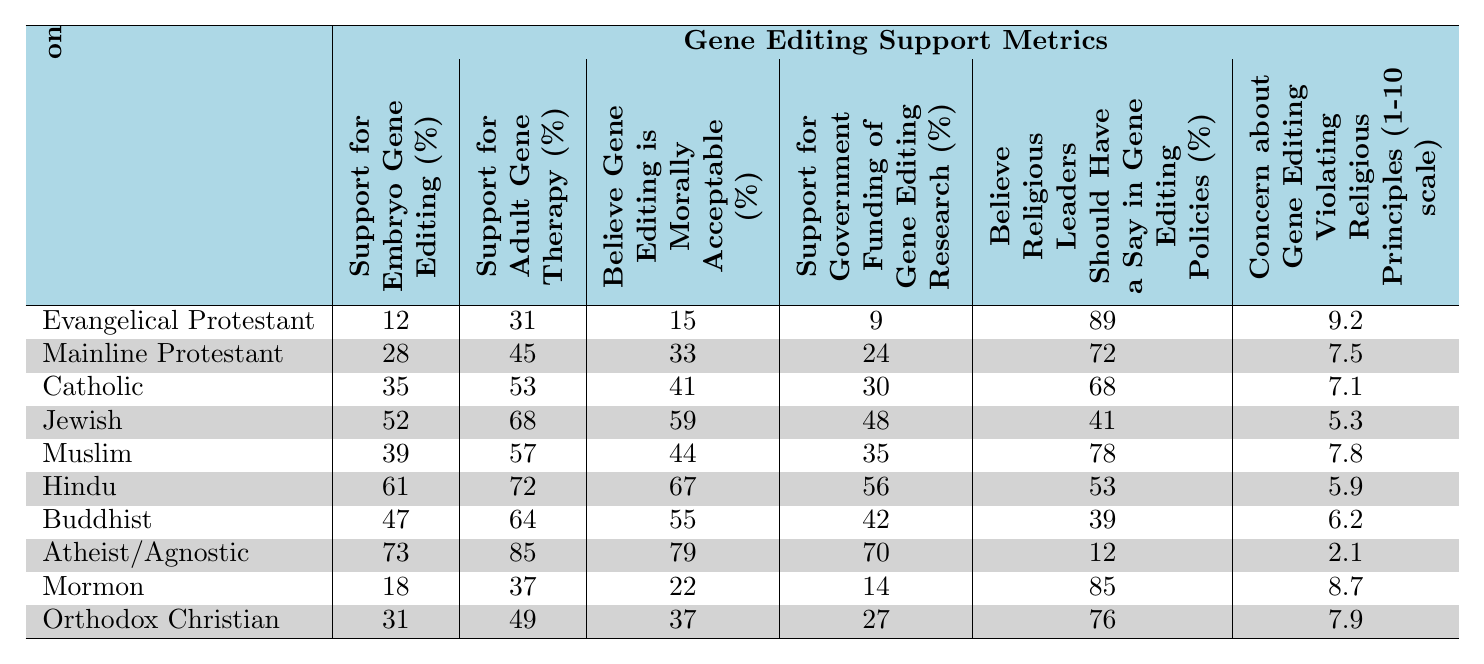What is the support percentage for embryo gene editing among Atheists/Agnostics? According to the table, the support percentage for embryo gene editing among Atheists/Agnostics is 73%.
Answer: 73% Which religious group has the highest support for adult gene therapy? The table shows that Atheists/Agnostics have the highest support for adult gene therapy at 85%.
Answer: 85% Do Evangelical Protestants believe gene editing is morally acceptable? Yes, according to the table, only 15% of Evangelical Protestants believe gene editing is morally acceptable.
Answer: Yes What is the difference in support for government funding of gene editing research between Jews and Catholics? The support for government funding among Jews is 48%, while for Catholics it is 30%. The difference is 48 - 30 = 18%.
Answer: 18% Which religious group has the lowest concern about gene editing violating religious principles? The table indicates that Atheists/Agnostics have the lowest concern at a score of 2.1 on a 1-10 scale.
Answer: 2.1 What is the average percentage of support for embryo gene editing among Mainline Protestants, Muslims, and Catholics? First, we add their support percentages: 28 (Mainline Protestants) + 39 (Muslims) + 35 (Catholics) = 102. There are three groups, so we divide 102 by 3, resulting in an average of 34%.
Answer: 34% Which group believes that religious leaders should not have a say in gene editing policies? Atheists/Agnostics believe that religious leaders should not have a say, as shown by their support percentage of only 12%.
Answer: Atheists/Agnostics What is the correlation between support for adult gene therapy and the belief that gene editing is morally acceptable for Jewish individuals? The support for adult gene therapy among Jews is 68%, while the percentage who believe gene editing is morally acceptable is 59%. Although this does not give a correlation coefficient, we can observe that both values are relatively high.
Answer: High What is the highest concern level about gene editing violating religious principles among the groups listed? The highest concern level is 9.2 and belongs to Evangelical Protestants, as indicated in the table.
Answer: 9.2 Calculate the median support for embryo gene editing based on the religious groups presented. To find the median, we first list the support percentages: 12, 28, 35, 52, 39, 61, 47, 73, 18, 31. Arranging them: 12, 18, 28, 31, 35, 39, 47, 52, 61, 73. The middle numbers (35 and 39) give us a median of (35 + 39) / 2 = 37%.
Answer: 37% 